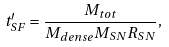<formula> <loc_0><loc_0><loc_500><loc_500>t ^ { \prime } _ { S F } = \frac { M _ { t o t } } { M _ { d e n s e } M _ { S N } R _ { S N } } ,</formula> 